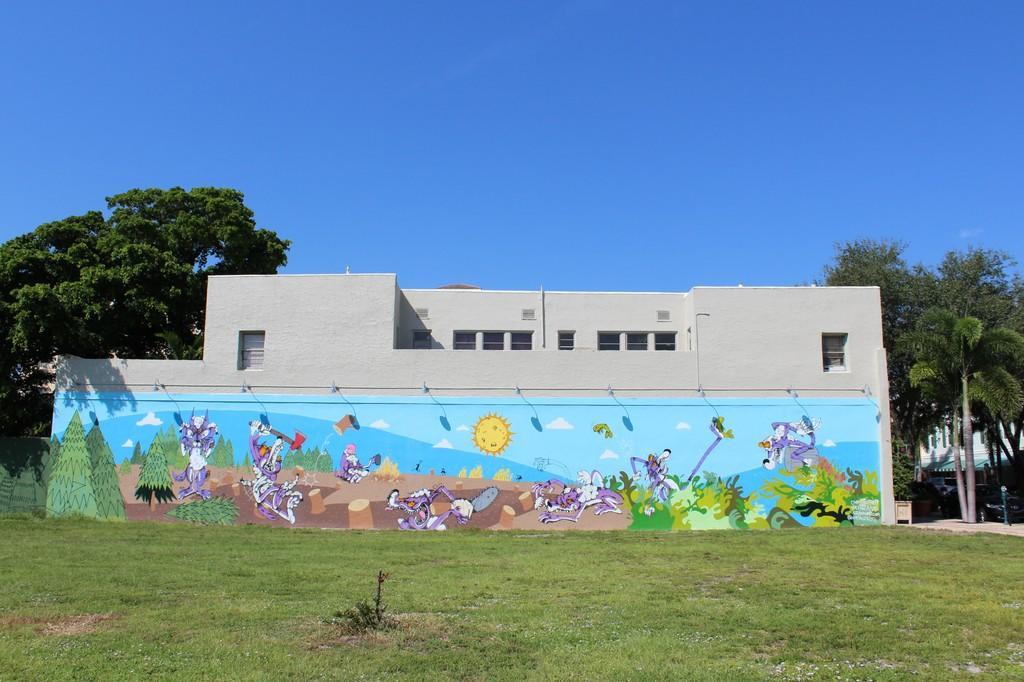Can you describe this image briefly? In the center of the image there is a house. There is a painting on the wall. At the bottom of the image there is grass. In the background of the image there are trees, sky. 